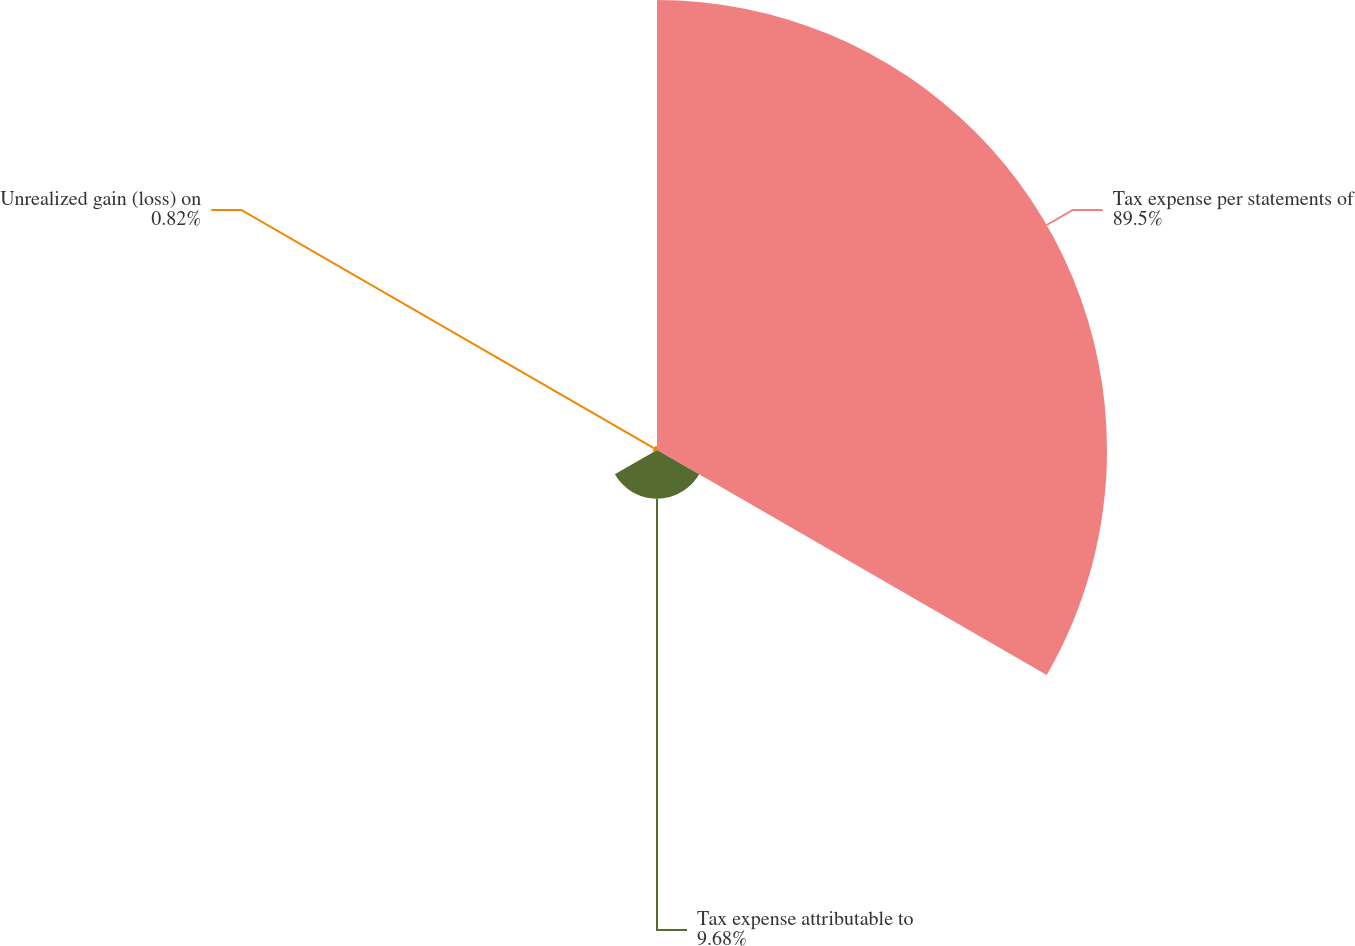Convert chart to OTSL. <chart><loc_0><loc_0><loc_500><loc_500><pie_chart><fcel>Tax expense per statements of<fcel>Tax expense attributable to<fcel>Unrealized gain (loss) on<nl><fcel>89.5%<fcel>9.68%<fcel>0.82%<nl></chart> 